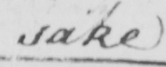Please transcribe the handwritten text in this image. sake 